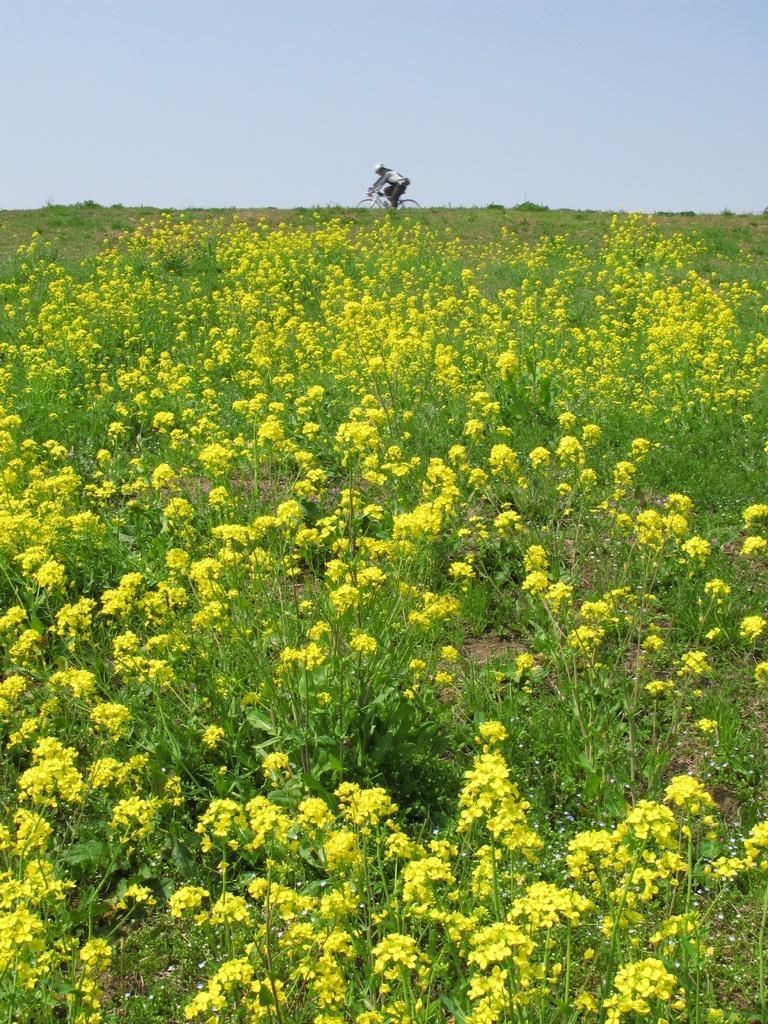Please provide a concise description of this image. In this image there are some plants with flowers as we can see at bottom of this image and there is one person is on bicycle at top of this image and there is a sky in the background. 